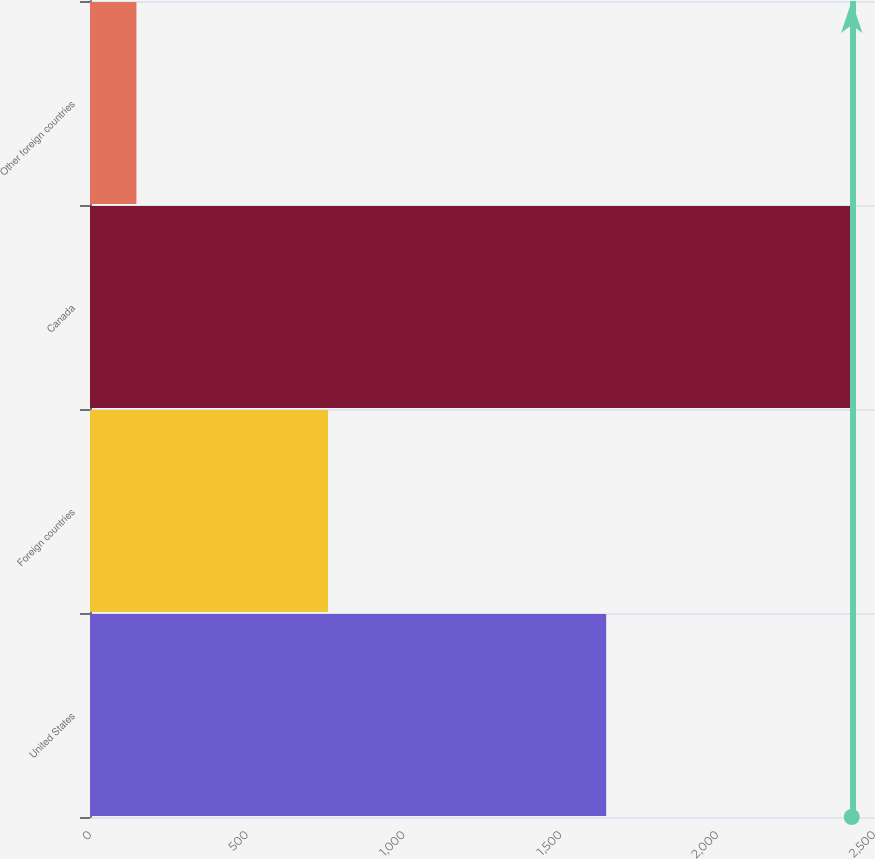Convert chart to OTSL. <chart><loc_0><loc_0><loc_500><loc_500><bar_chart><fcel>United States<fcel>Foreign countries<fcel>Canada<fcel>Other foreign countries<nl><fcel>1646<fcel>759<fcel>2429<fcel>148<nl></chart> 